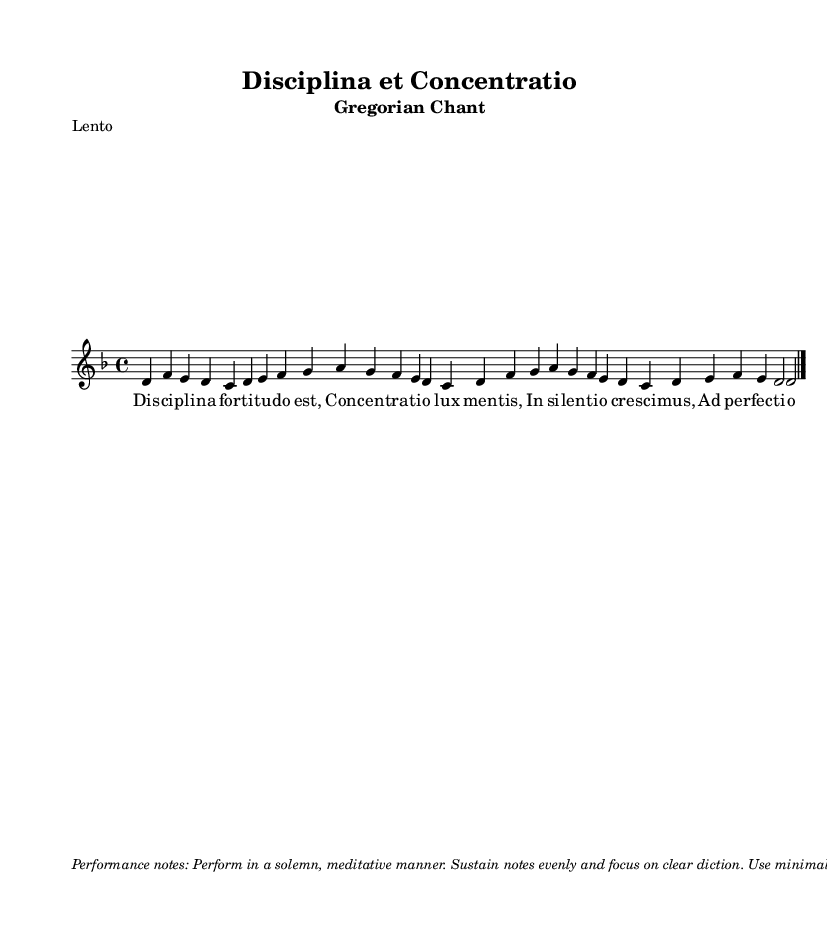What is the key signature of this music? The key signature is indicated at the beginning of the score, showing two flats. The key of D minor has one flat (B flat), with A and C natural being a common variation.
Answer: D minor What is the time signature of this piece? The time signature is expressed in the notation at the beginning of the piece, represented as a fraction with a 4 on the top and a 4 on the bottom, indicating a four-beat measure and a quarter note gets the beat.
Answer: 4/4 What is the title of this piece? The title is presented at the top of the sheet music, prominently displayed; it reads "Disciplina et Concentratio."
Answer: Disciplina et Concentratio How many measures are in the melody? To find the number of measures, count each four-beat grouping indicated by vertical lines on the staff; there are eight measures in the melody section.
Answer: 8 What performance notes are provided for this chant? The performance notes can be found at the bottom of the score, providing guidelines on how to express the chant; the notes emphasize a solemn and meditative performance with minimal vibrato.
Answer: Perform in a solemn, meditative manner What is the texture of this Gregorian chant indicated in the markup? The markup suggests that this chant should be performed a cappella, meaning without instrumental accompaniment, indicating a vocal texture only.
Answer: A cappella 